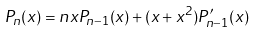<formula> <loc_0><loc_0><loc_500><loc_500>P _ { n } ( x ) = n x P _ { n - 1 } ( x ) + ( x + x ^ { 2 } ) P ^ { \prime } _ { n - 1 } ( x )</formula> 